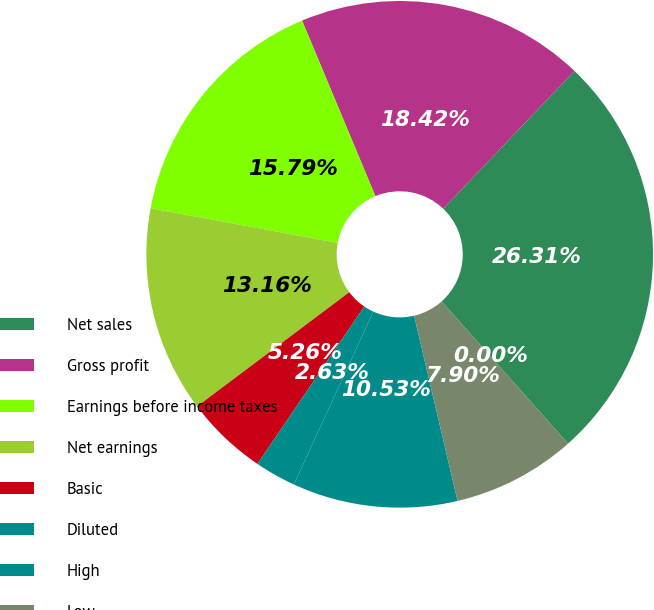Convert chart. <chart><loc_0><loc_0><loc_500><loc_500><pie_chart><fcel>Net sales<fcel>Gross profit<fcel>Earnings before income taxes<fcel>Net earnings<fcel>Basic<fcel>Diluted<fcel>High<fcel>Low<fcel>Dividends declared per share<nl><fcel>26.31%<fcel>18.42%<fcel>15.79%<fcel>13.16%<fcel>5.26%<fcel>2.63%<fcel>10.53%<fcel>7.9%<fcel>0.0%<nl></chart> 